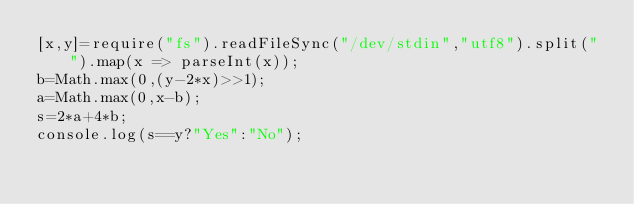Convert code to text. <code><loc_0><loc_0><loc_500><loc_500><_JavaScript_>[x,y]=require("fs").readFileSync("/dev/stdin","utf8").split(" ").map(x => parseInt(x));
b=Math.max(0,(y-2*x)>>1);
a=Math.max(0,x-b);
s=2*a+4*b;
console.log(s==y?"Yes":"No");</code> 